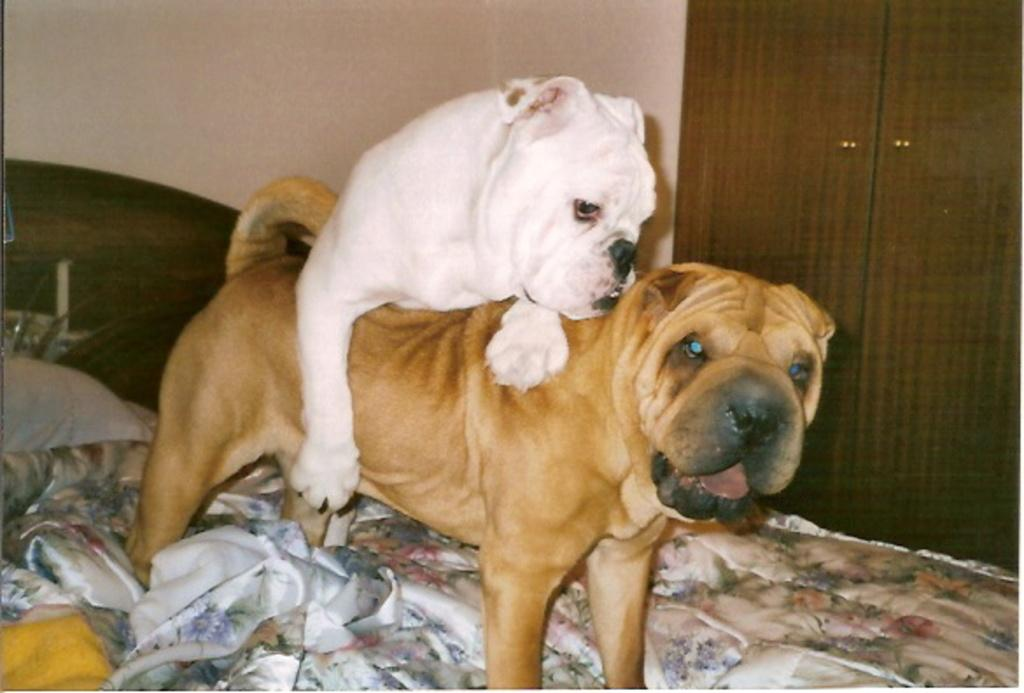What animals can be seen on the bed in the image? There are two dogs on the bed. What architectural feature is visible in the image? There is a door visible in the image. What type of surface is visible in the image? There is a wall visible in the image. What type of lettuce is being used as a pillow for the dogs in the image? There is no lettuce present in the image, and the dogs are not using any lettuce as a pillow. 